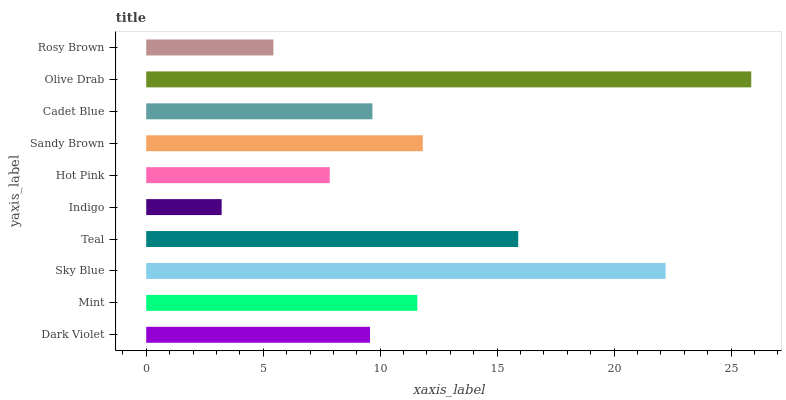Is Indigo the minimum?
Answer yes or no. Yes. Is Olive Drab the maximum?
Answer yes or no. Yes. Is Mint the minimum?
Answer yes or no. No. Is Mint the maximum?
Answer yes or no. No. Is Mint greater than Dark Violet?
Answer yes or no. Yes. Is Dark Violet less than Mint?
Answer yes or no. Yes. Is Dark Violet greater than Mint?
Answer yes or no. No. Is Mint less than Dark Violet?
Answer yes or no. No. Is Mint the high median?
Answer yes or no. Yes. Is Cadet Blue the low median?
Answer yes or no. Yes. Is Olive Drab the high median?
Answer yes or no. No. Is Mint the low median?
Answer yes or no. No. 